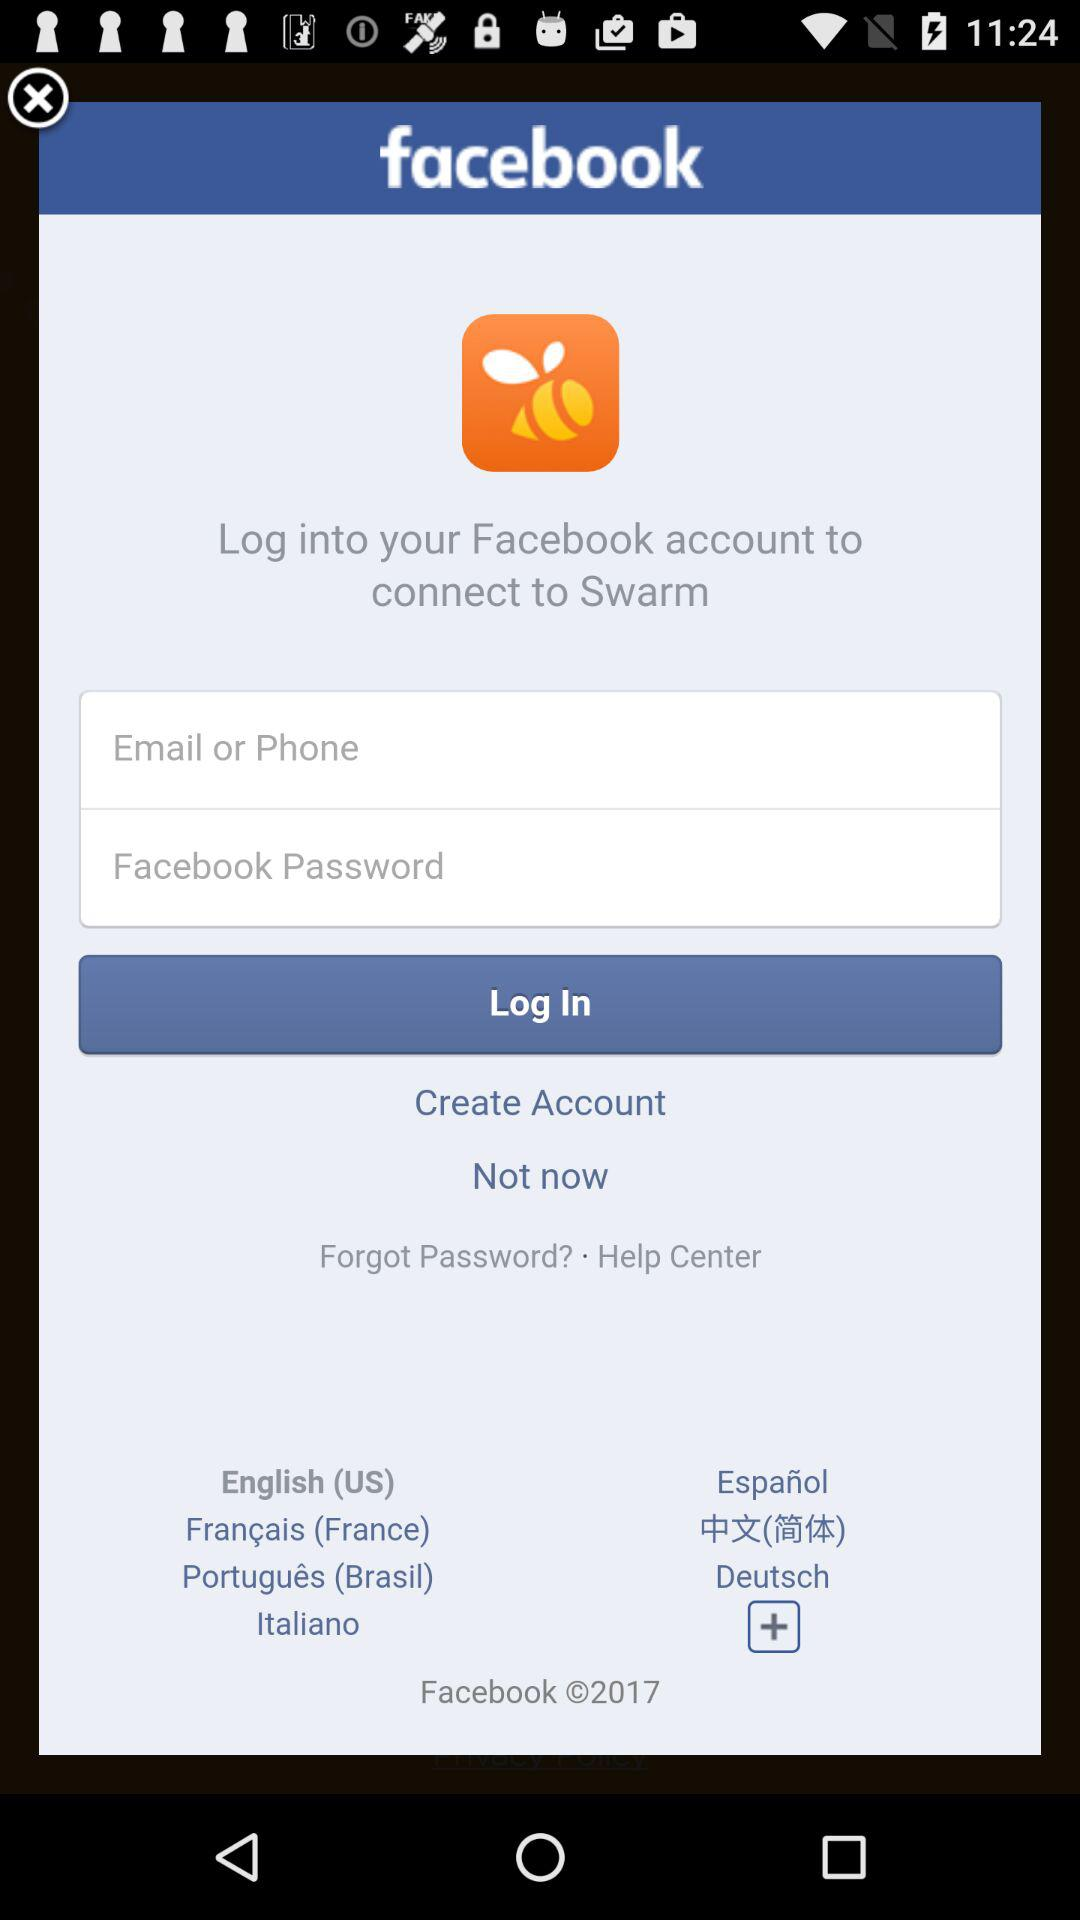How many languages are available for the user to select?
Answer the question using a single word or phrase. 7 